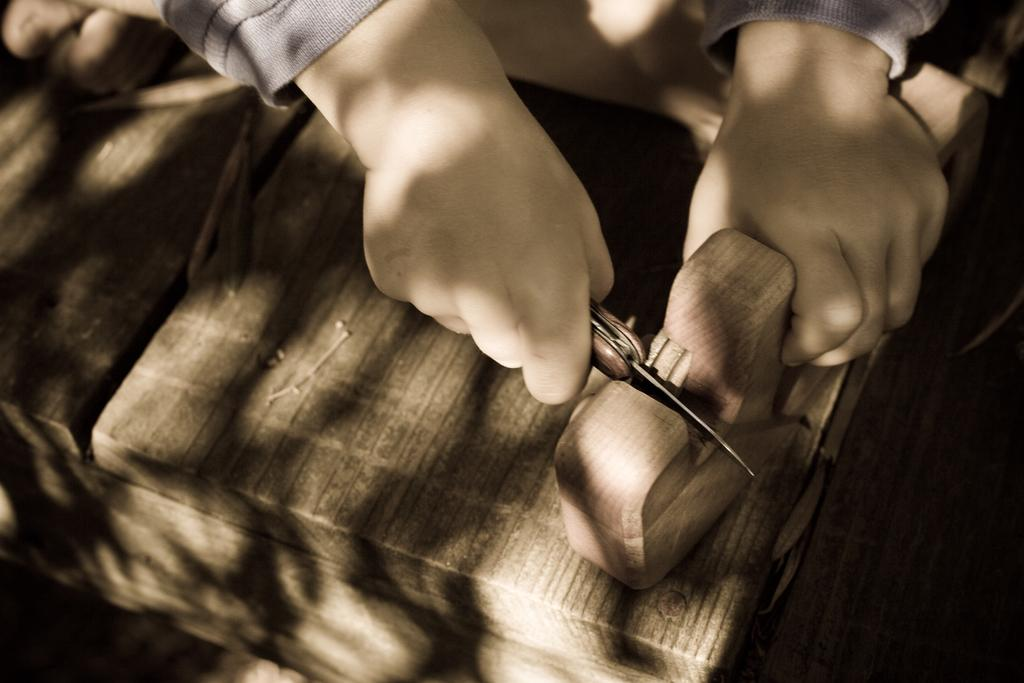What is the main subject of the image? There is a person in the image. What is the person holding in their hand? The person is holding a knife and a wooden object. What might the person be doing with the knife and wooden object? It appears that the person is cutting an object. What type of books can be seen on the person's head in the image? There are no books present in the image, and the person is not holding any books on their head. 